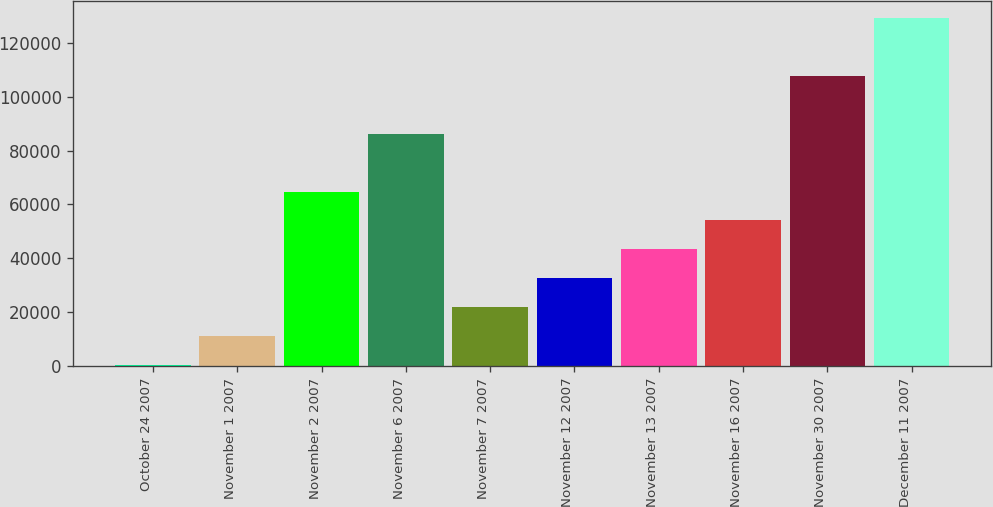Convert chart. <chart><loc_0><loc_0><loc_500><loc_500><bar_chart><fcel>October 24 2007<fcel>November 1 2007<fcel>November 2 2007<fcel>November 6 2007<fcel>November 7 2007<fcel>November 12 2007<fcel>November 13 2007<fcel>November 16 2007<fcel>November 30 2007<fcel>December 11 2007<nl><fcel>417<fcel>11145.3<fcel>64786.8<fcel>86243.4<fcel>21873.6<fcel>32601.9<fcel>43330.2<fcel>54058.5<fcel>107700<fcel>129157<nl></chart> 